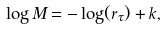Convert formula to latex. <formula><loc_0><loc_0><loc_500><loc_500>\log { M } = - \log ( r _ { \tau } ) + k ,</formula> 